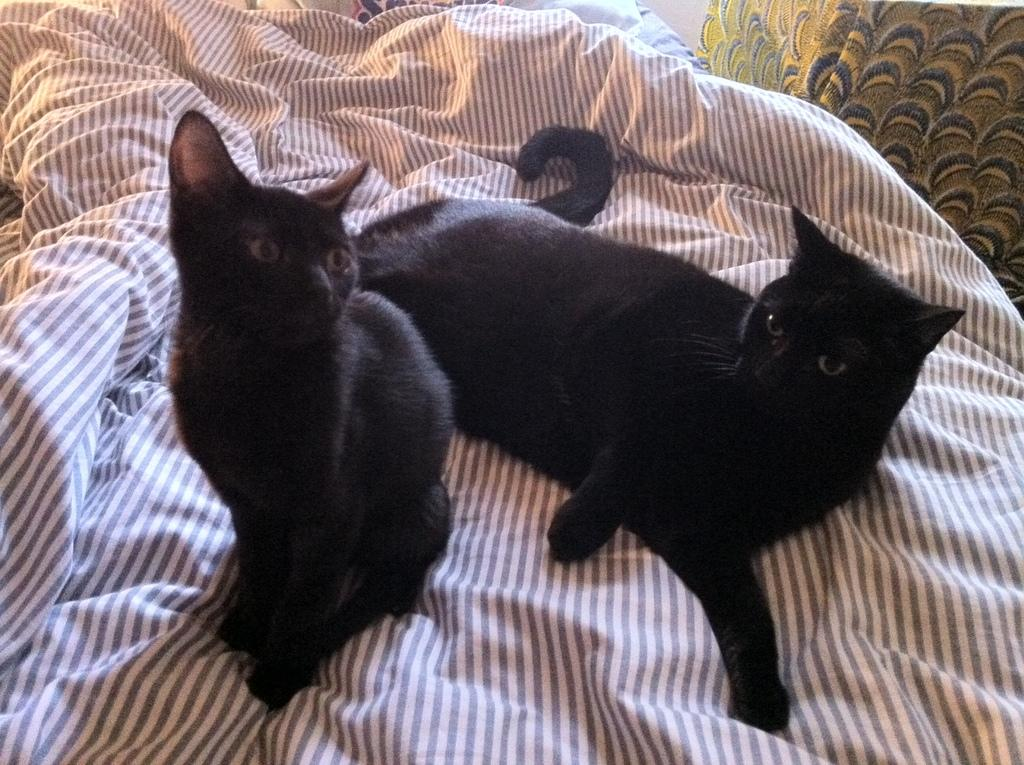How many cats are present in the image? There are 2 black color cats in the image. What is the color of the cats? The cats are black. Where are the cats located in the image? The cats are on a cloth. Can you describe the cloth in the image? The cloth is of white and brown color. Are there any other cats in the image besides the two black ones? Yes, there is another cat in the top right corner of the image. What channel is the cat watching on the television in the image? There is no television present in the image, so it is not possible to determine what channel the cat might be watching. 